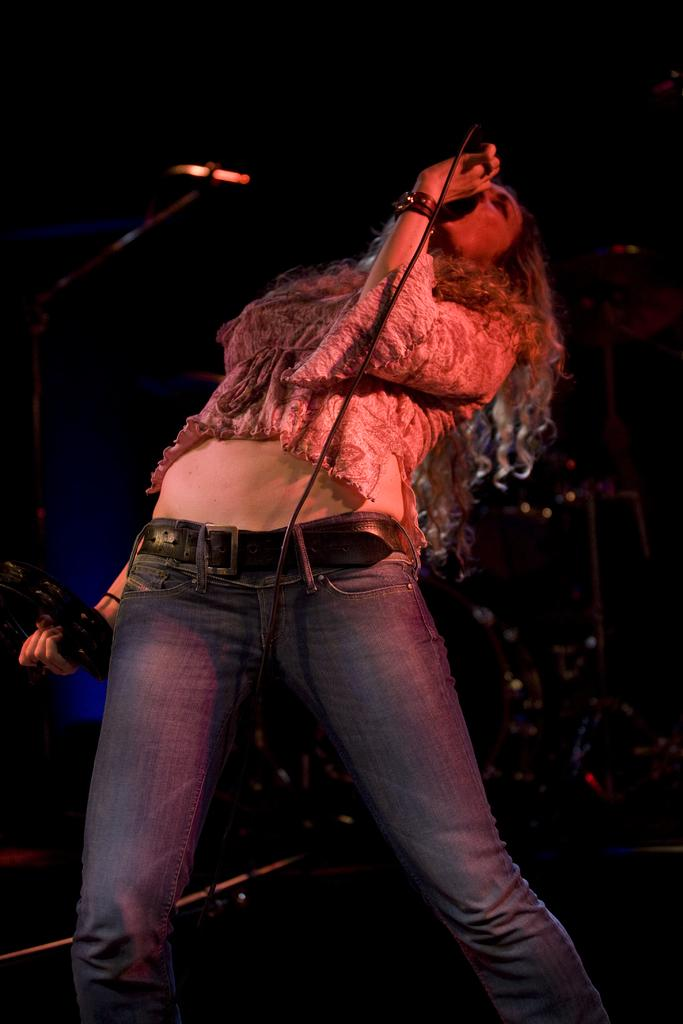Who is the main subject in the image? There is a lady in the center of the image. What is the lady doing in the image? The lady is standing and holding a mic in her hand. What can be seen in the background of the image? There is a band in the background of the image. How many icicles are hanging from the lady's hair in the image? There are no icicles present in the image. 